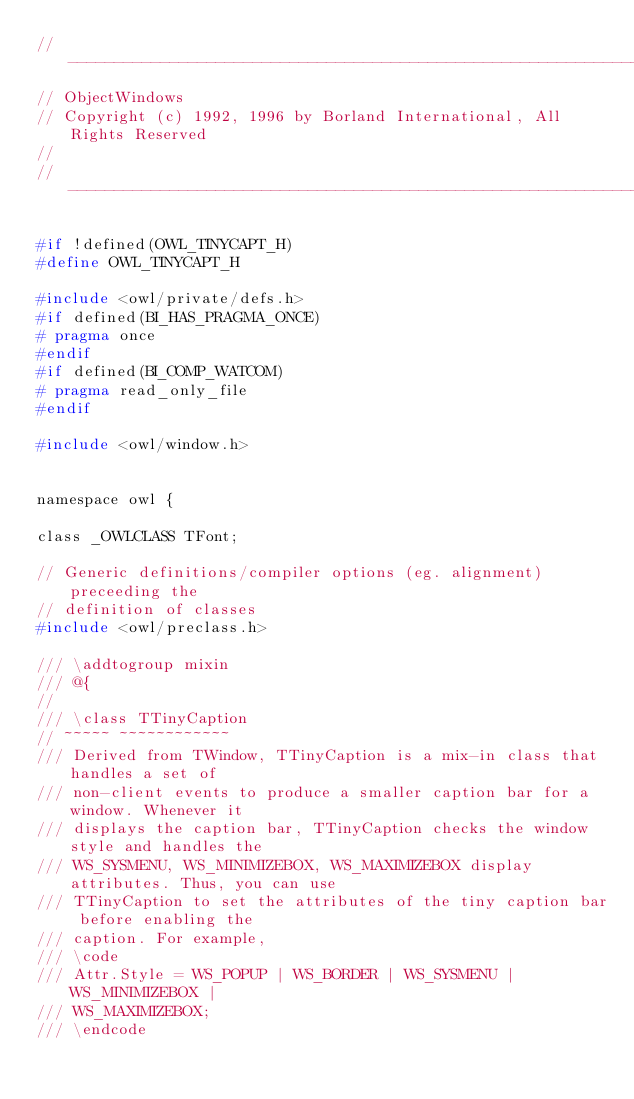Convert code to text. <code><loc_0><loc_0><loc_500><loc_500><_C_>//----------------------------------------------------------------------------
// ObjectWindows
// Copyright (c) 1992, 1996 by Borland International, All Rights Reserved
//
//----------------------------------------------------------------------------

#if !defined(OWL_TINYCAPT_H)
#define OWL_TINYCAPT_H

#include <owl/private/defs.h>
#if defined(BI_HAS_PRAGMA_ONCE)
# pragma once
#endif
#if defined(BI_COMP_WATCOM)
# pragma read_only_file
#endif

#include <owl/window.h>


namespace owl {

class _OWLCLASS TFont;

// Generic definitions/compiler options (eg. alignment) preceeding the 
// definition of classes
#include <owl/preclass.h>

/// \addtogroup mixin
/// @{
//
/// \class TTinyCaption
// ~~~~~ ~~~~~~~~~~~~
/// Derived from TWindow, TTinyCaption is a mix-in class that handles a set of
/// non-client events to produce a smaller caption bar for a window. Whenever it
/// displays the caption bar, TTinyCaption checks the window style and handles the
/// WS_SYSMENU, WS_MINIMIZEBOX, WS_MAXIMIZEBOX display attributes. Thus, you can use
/// TTinyCaption to set the attributes of the tiny caption bar before enabling the
/// caption. For example,
/// \code
/// Attr.Style = WS_POPUP | WS_BORDER | WS_SYSMENU | WS_MINIMIZEBOX |
/// WS_MAXIMIZEBOX;
/// \endcode</code> 